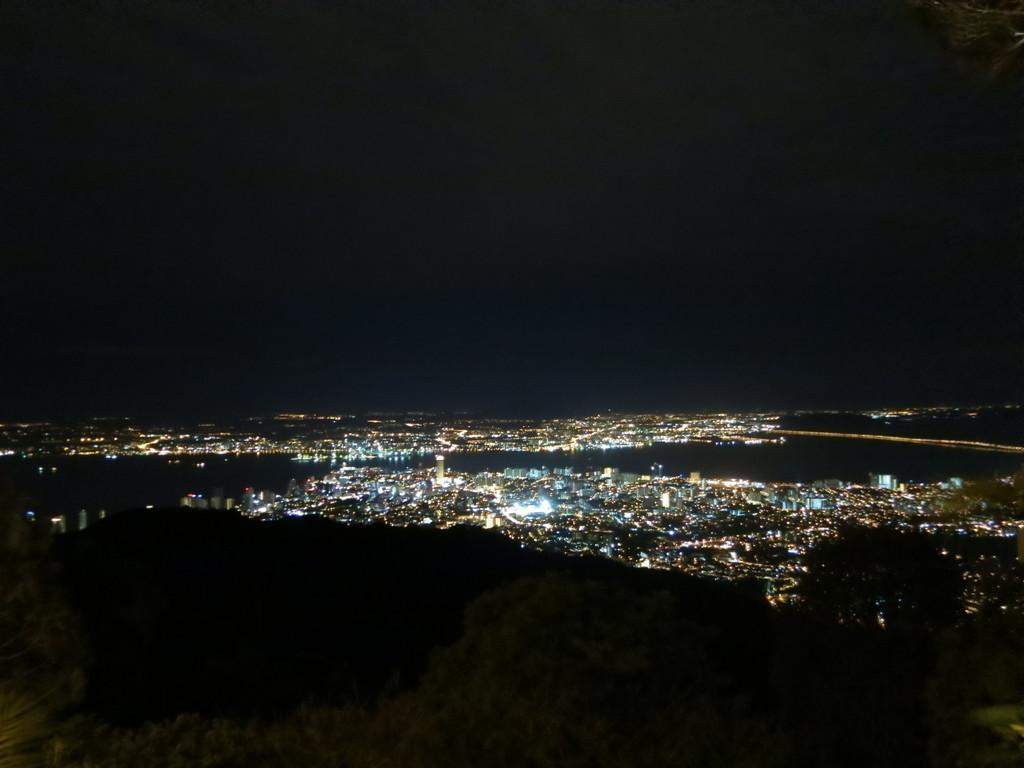What type of structures can be seen in the image? There are buildings visible in the image. What else can be seen in the image besides the buildings? There are lights visible in the image. What type of bone is present in the image? There is no bone present in the image; it only features buildings and lights. 